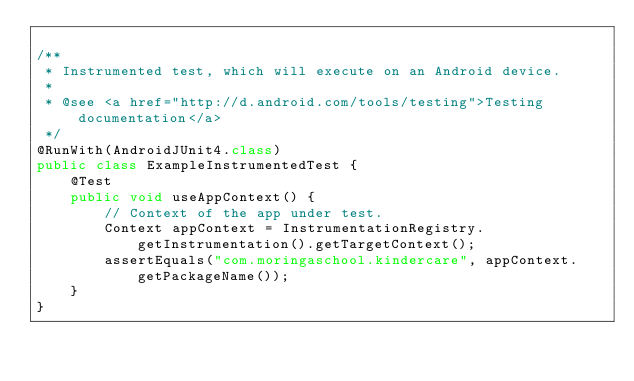Convert code to text. <code><loc_0><loc_0><loc_500><loc_500><_Java_>
/**
 * Instrumented test, which will execute on an Android device.
 *
 * @see <a href="http://d.android.com/tools/testing">Testing documentation</a>
 */
@RunWith(AndroidJUnit4.class)
public class ExampleInstrumentedTest {
    @Test
    public void useAppContext() {
        // Context of the app under test.
        Context appContext = InstrumentationRegistry.getInstrumentation().getTargetContext();
        assertEquals("com.moringaschool.kindercare", appContext.getPackageName());
    }
}</code> 